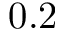<formula> <loc_0><loc_0><loc_500><loc_500>0 . 2</formula> 